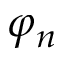<formula> <loc_0><loc_0><loc_500><loc_500>\varphi _ { n }</formula> 